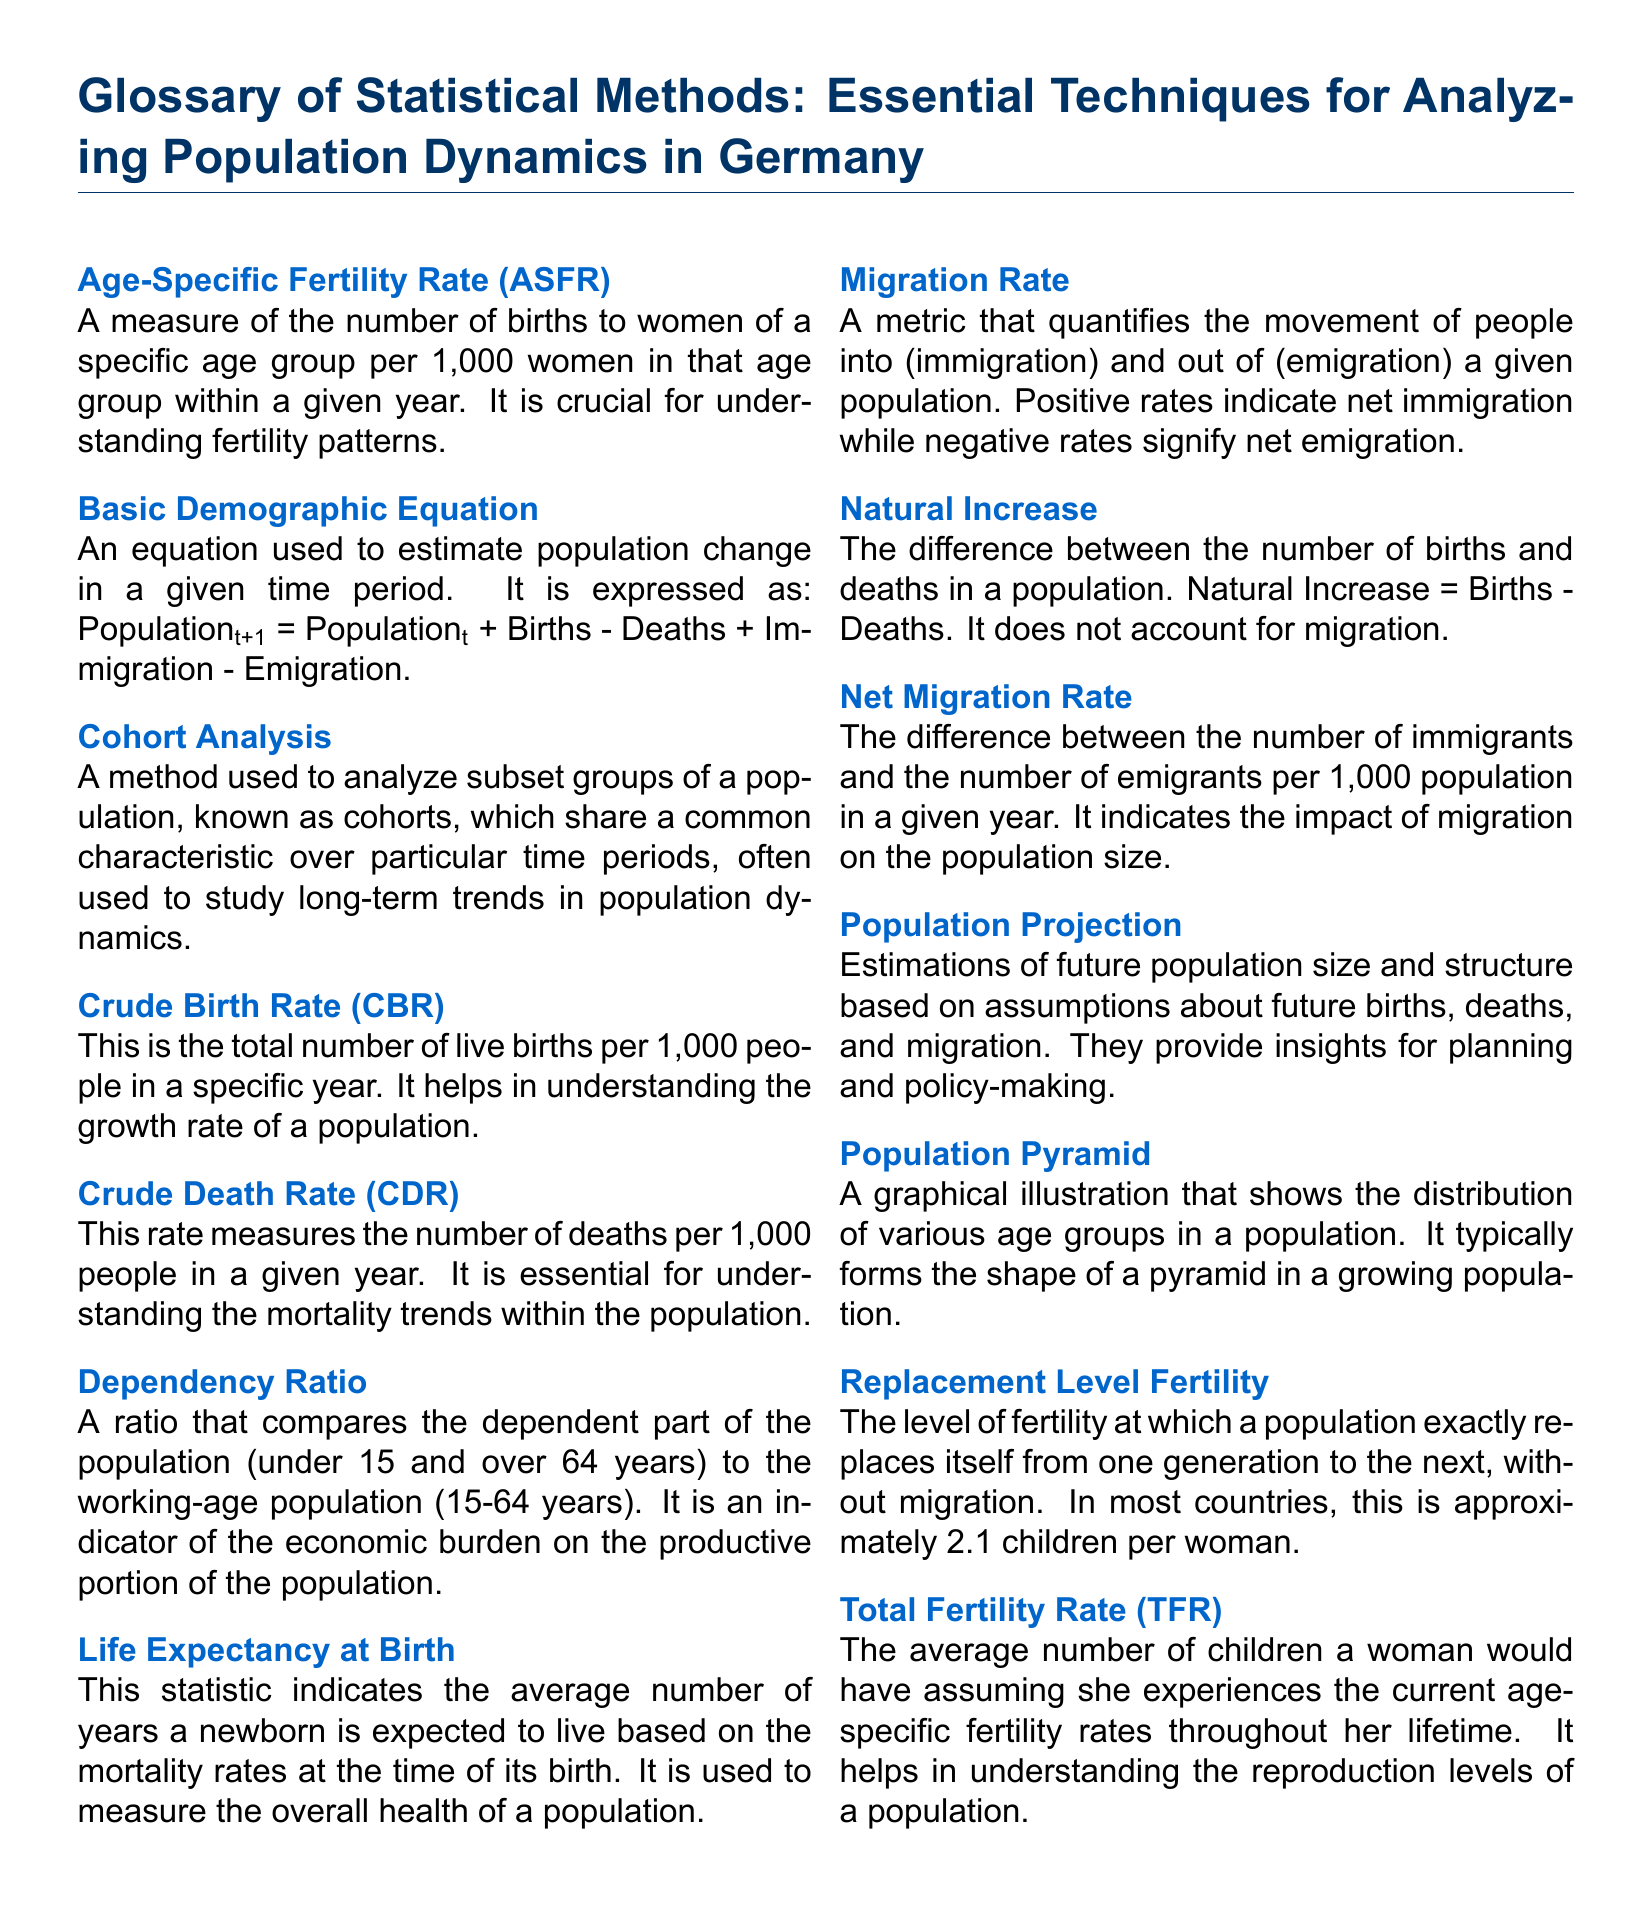what is the average number of children a woman would have? The Total Fertility Rate indicates this average number, providing insight into reproduction levels, which is represented as "2.1 children per woman."
Answer: 2.1 children what does ASFR stand for? ASFR is an abbreviation used in the glossary to represent Age-Specific Fertility Rate, which measures births to women in a specific age group.
Answer: Age-Specific Fertility Rate what is the formula for the Basic Demographic Equation? The Basic Demographic Equation is expressed as: Population_t+1 = Population_t + Births - Deaths + Immigration - Emigration, summarizing population change.
Answer: Population_t+1 = Population_t + Births - Deaths + Immigration - Emigration what is the dependency ratio? The dependency ratio compares the dependent segment of the population to the working-age population, assessing economic burdens.
Answer: A ratio what does natural increase measure? Natural Increase is defined as the difference between the number of births and deaths in a population, indicating overall population growth excluding migration.
Answer: Births - Deaths what is indicated by a negative migration rate? A negative migration rate signifies net emigration, showing more people leaving than entering the population.
Answer: Net emigration how is life expectancy at birth measured? Life Expectancy at Birth illustrates the average number of years a newborn is expected to live, based on current mortality rates.
Answer: Average years what does the population pyramid show? A population pyramid graphically illustrates the age distribution of various groups in a population, useful for demographic analysis.
Answer: Age distribution what is the significance of the crude death rate (CDR)? The Crude Death Rate measures deaths per 1,000 people in a given year, crucial for understanding mortality trends in a population.
Answer: Deaths per 1,000 people what is the purpose of population projections? Population projections estimate future population size and structure based on assumptions about births, deaths, and migration, aiding planning.
Answer: Estimations of future population size and structure 